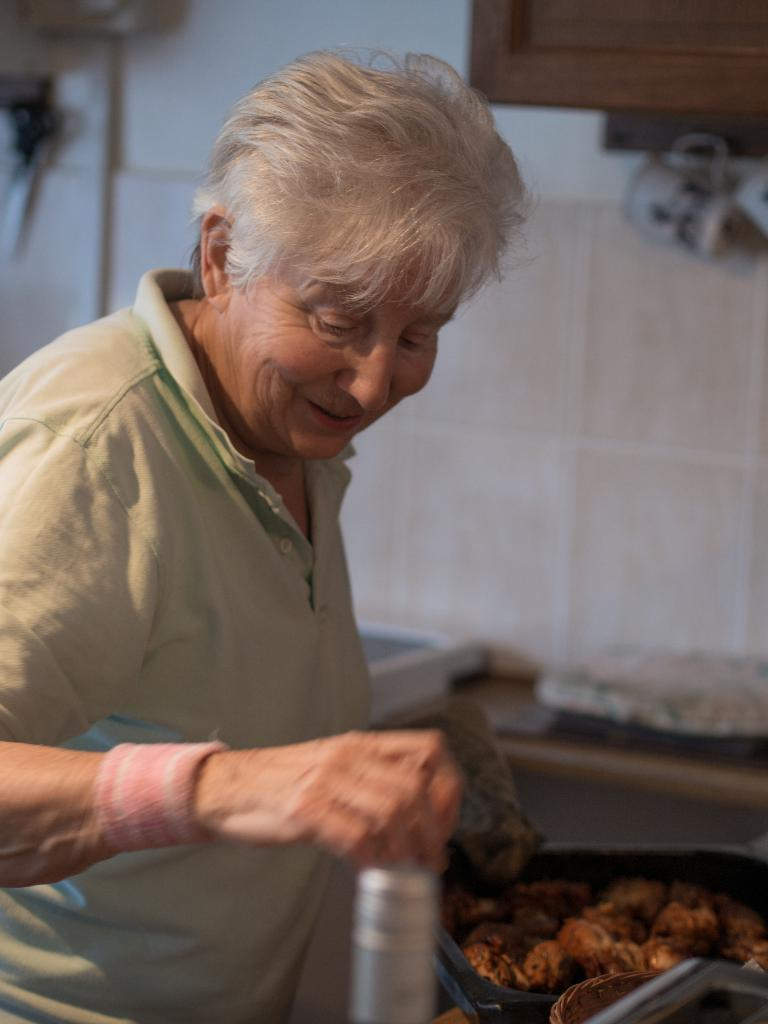What is the main subject of the image? There is a person in the image. What is in front of the person? There are food items in front of the person. What is the person holding in the image? The person is holding a bottle. Can you describe the background of the person? The background of the person is blurred. Is there an earthquake happening in the image? There is no indication of an earthquake in the image. What type of dog can be seen interacting with the person in the image? There is no dog present in the image. 